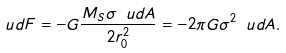Convert formula to latex. <formula><loc_0><loc_0><loc_500><loc_500>\ u d F = - G \frac { M _ { S } \sigma \ u d A } { 2 r _ { 0 } ^ { 2 } } = - 2 \pi G \sigma ^ { 2 } \ u d A .</formula> 